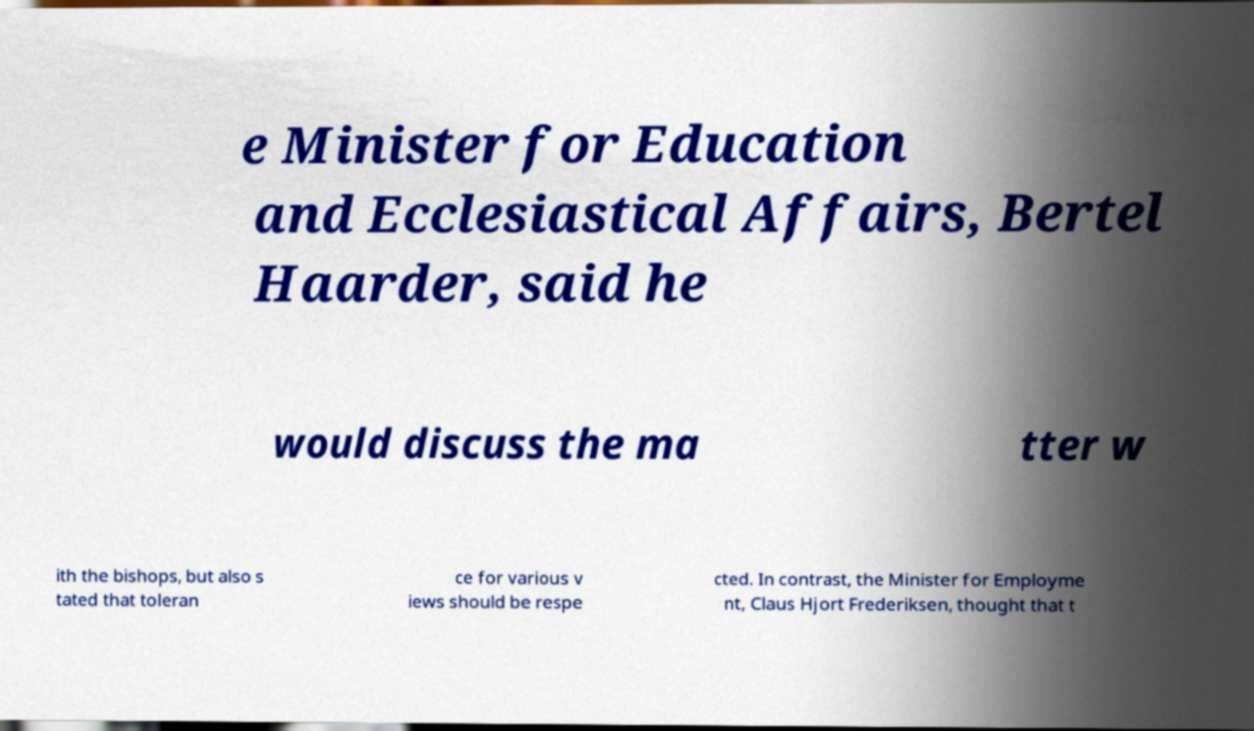I need the written content from this picture converted into text. Can you do that? e Minister for Education and Ecclesiastical Affairs, Bertel Haarder, said he would discuss the ma tter w ith the bishops, but also s tated that toleran ce for various v iews should be respe cted. In contrast, the Minister for Employme nt, Claus Hjort Frederiksen, thought that t 